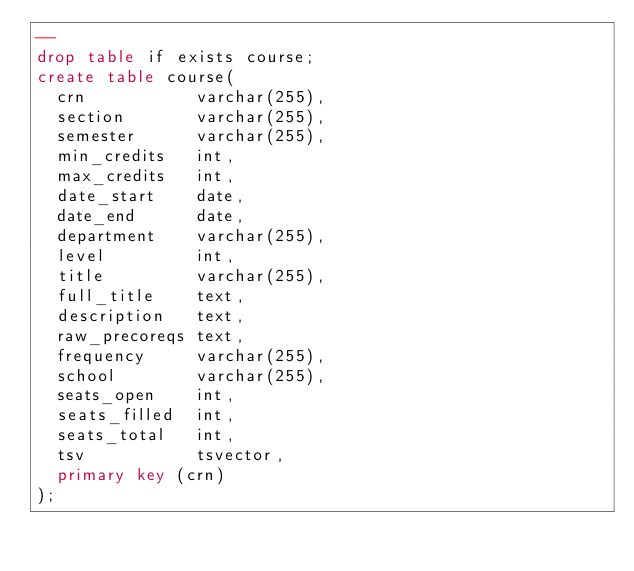Convert code to text. <code><loc_0><loc_0><loc_500><loc_500><_SQL_>--
drop table if exists course;
create table course(
  crn           varchar(255),
  section       varchar(255),
  semester      varchar(255),
  min_credits   int,
  max_credits   int,
  date_start    date,
  date_end      date,
  department    varchar(255),
  level         int,
  title         varchar(255),
  full_title    text,
  description   text,
  raw_precoreqs text,
  frequency     varchar(255),
  school        varchar(255),
  seats_open    int,
  seats_filled  int,
  seats_total   int,
  tsv           tsvector,
  primary key (crn)
);
</code> 